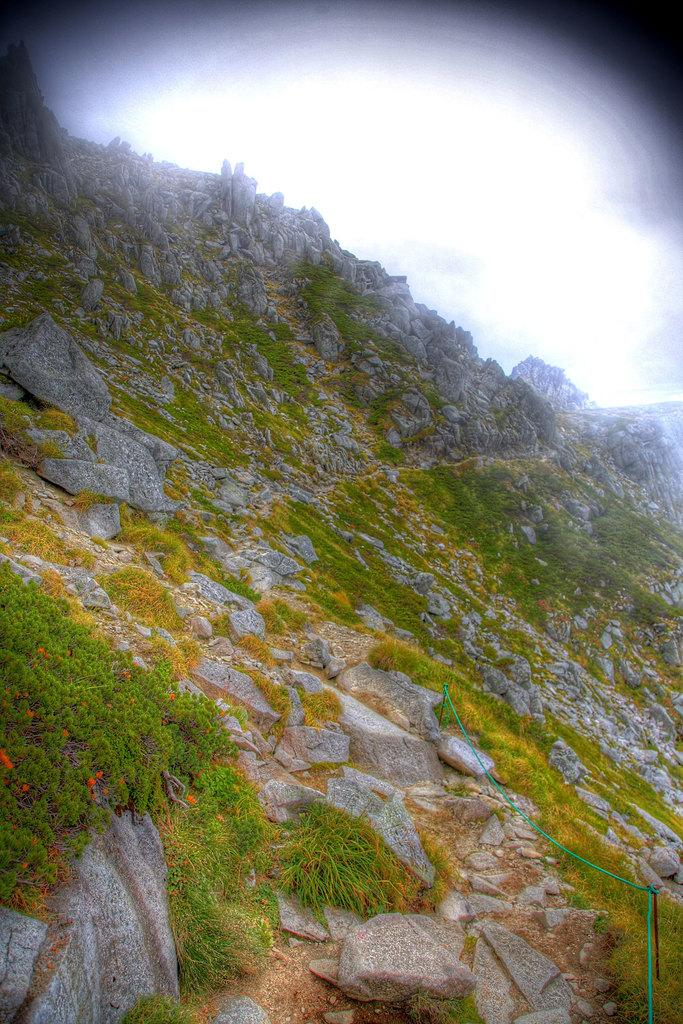What type of vegetation can be seen in the image? There is grass in the image. What other objects can be seen in the image? There are rocks and plants on the hill in the image. What is visible in the sky in the background of the image? There are clouds in the sky in the background of the image. What type of cork can be seen in the image? There is no cork present in the image. What is the tin used for in the image? There is no tin present in the image. 